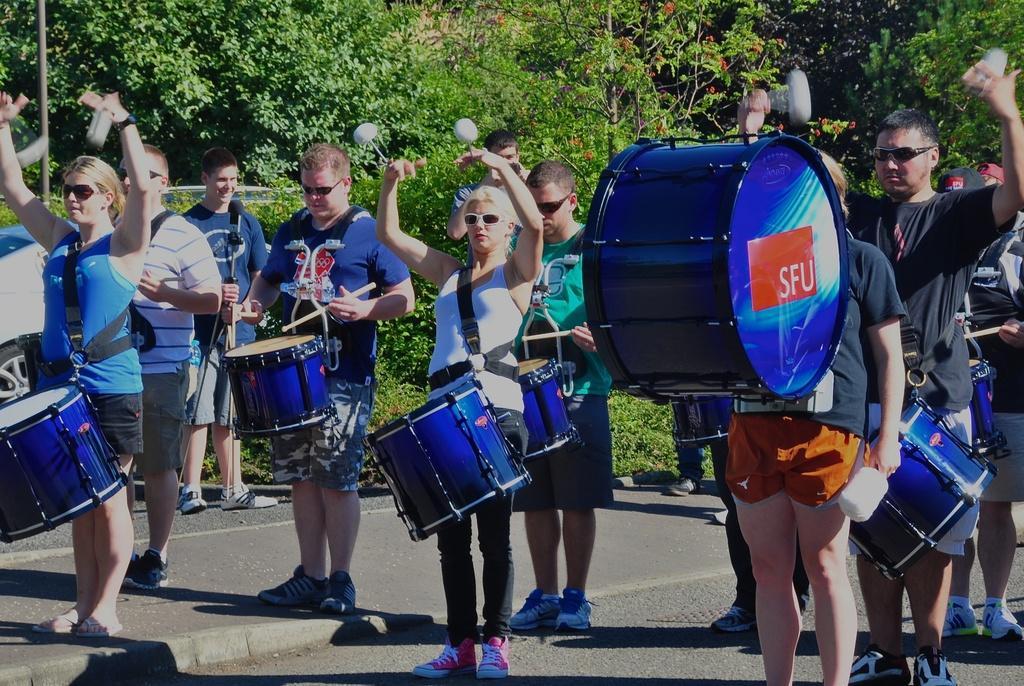How would you summarize this image in a sentence or two? In this image we can many people playing musical instruments. There are many trees in the image. There is a vehicle at the left side of the image. 